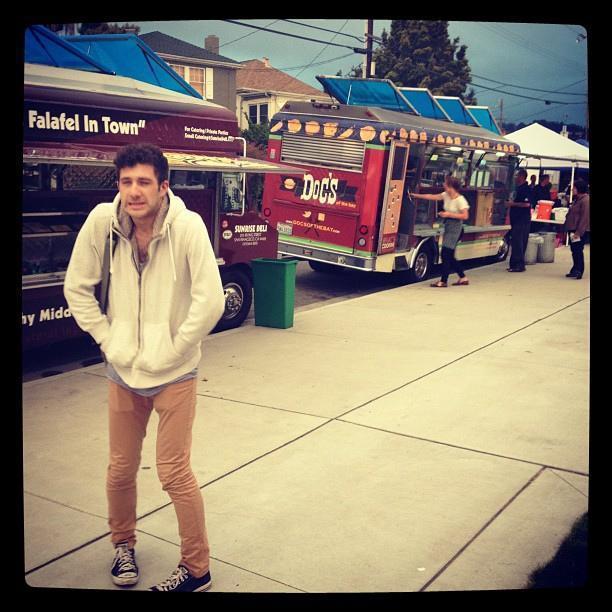How many people can you see?
Give a very brief answer. 3. How many trucks are there?
Give a very brief answer. 2. 